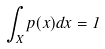<formula> <loc_0><loc_0><loc_500><loc_500>\int _ { X } p ( x ) d x = 1</formula> 